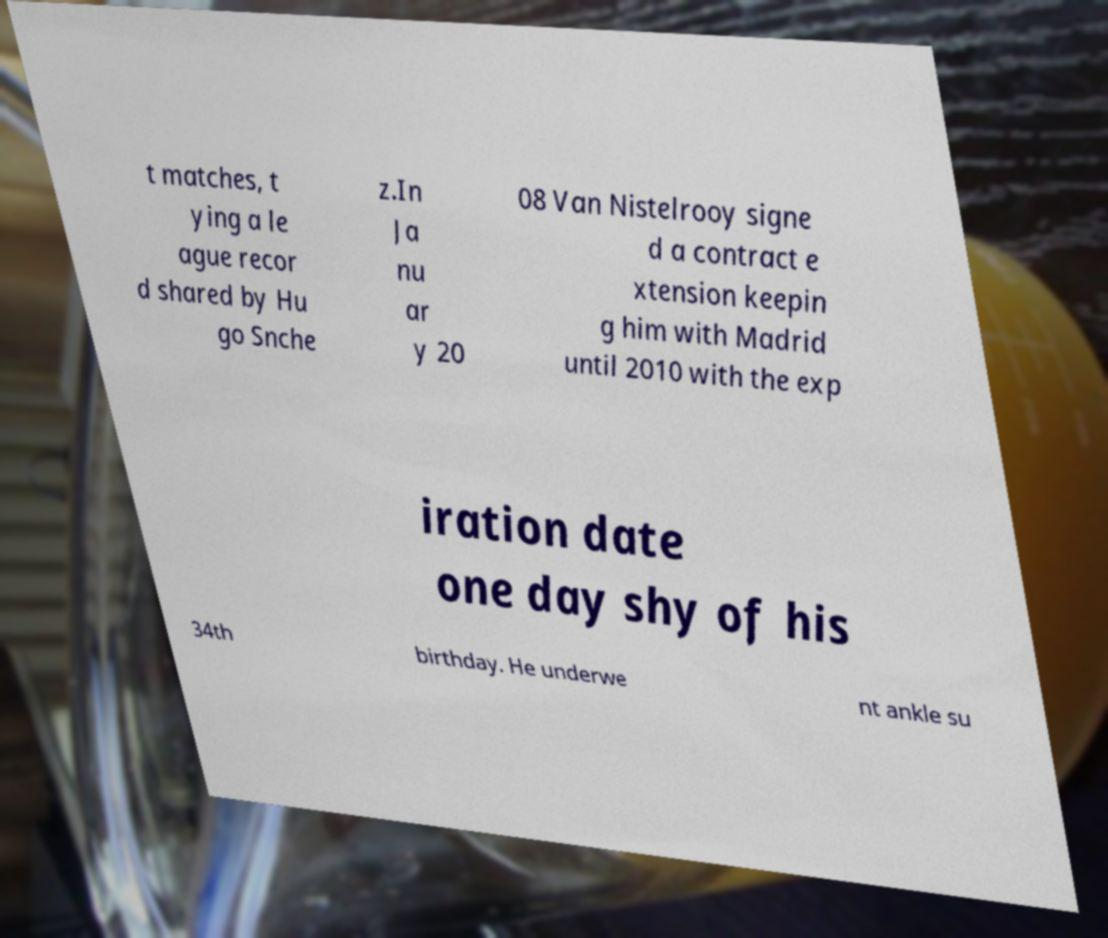Can you read and provide the text displayed in the image?This photo seems to have some interesting text. Can you extract and type it out for me? t matches, t ying a le ague recor d shared by Hu go Snche z.In Ja nu ar y 20 08 Van Nistelrooy signe d a contract e xtension keepin g him with Madrid until 2010 with the exp iration date one day shy of his 34th birthday. He underwe nt ankle su 